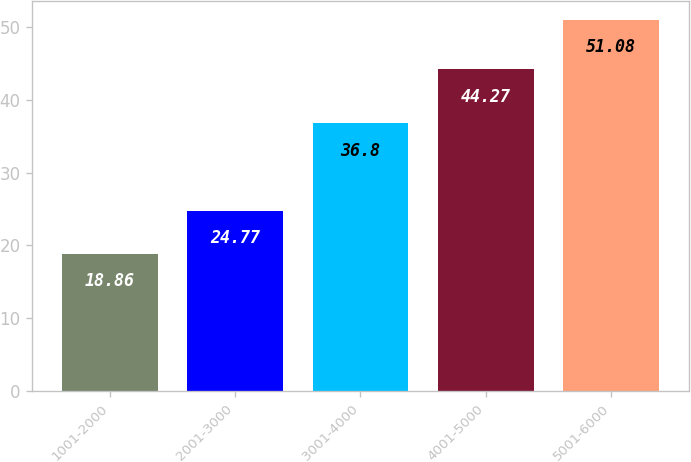Convert chart. <chart><loc_0><loc_0><loc_500><loc_500><bar_chart><fcel>1001-2000<fcel>2001-3000<fcel>3001-4000<fcel>4001-5000<fcel>5001-6000<nl><fcel>18.86<fcel>24.77<fcel>36.8<fcel>44.27<fcel>51.08<nl></chart> 